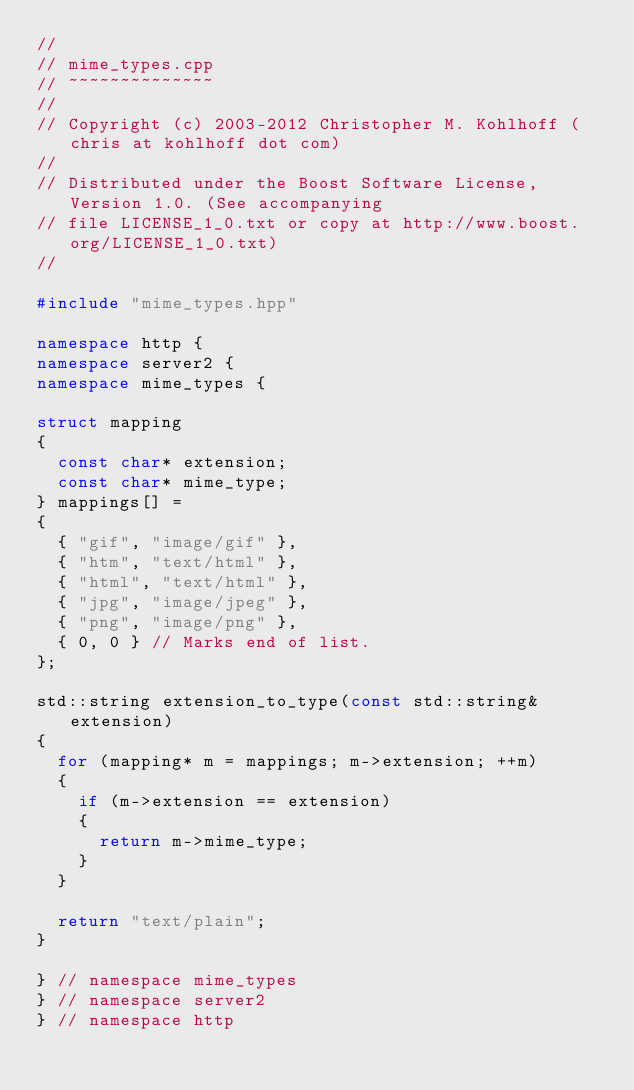Convert code to text. <code><loc_0><loc_0><loc_500><loc_500><_C++_>//
// mime_types.cpp
// ~~~~~~~~~~~~~~
//
// Copyright (c) 2003-2012 Christopher M. Kohlhoff (chris at kohlhoff dot com)
//
// Distributed under the Boost Software License, Version 1.0. (See accompanying
// file LICENSE_1_0.txt or copy at http://www.boost.org/LICENSE_1_0.txt)
//

#include "mime_types.hpp"

namespace http {
namespace server2 {
namespace mime_types {

struct mapping
{
  const char* extension;
  const char* mime_type;
} mappings[] =
{
  { "gif", "image/gif" },
  { "htm", "text/html" },
  { "html", "text/html" },
  { "jpg", "image/jpeg" },
  { "png", "image/png" },
  { 0, 0 } // Marks end of list.
};

std::string extension_to_type(const std::string& extension)
{
  for (mapping* m = mappings; m->extension; ++m)
  {
    if (m->extension == extension)
    {
      return m->mime_type;
    }
  }

  return "text/plain";
}

} // namespace mime_types
} // namespace server2
} // namespace http
</code> 